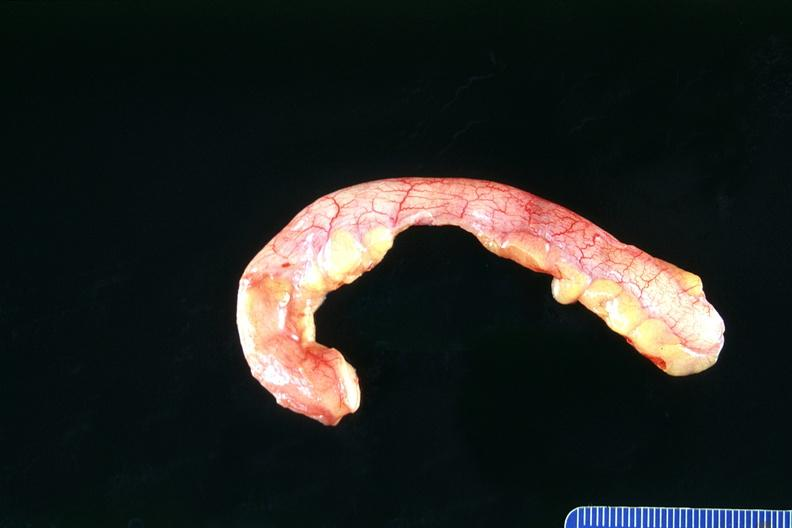does this image show normal appendix?
Answer the question using a single word or phrase. Yes 